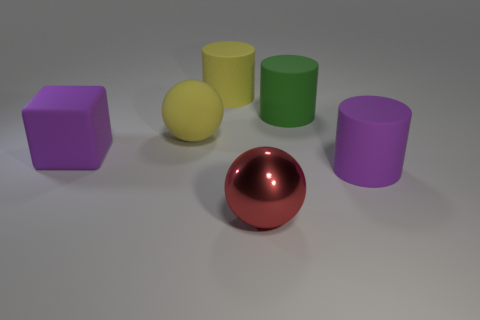Subtract 1 cylinders. How many cylinders are left? 2 Add 3 cylinders. How many objects exist? 9 Add 2 big cylinders. How many big cylinders exist? 5 Subtract 0 gray blocks. How many objects are left? 6 Subtract all spheres. How many objects are left? 4 Subtract all large red shiny things. Subtract all large purple matte cylinders. How many objects are left? 4 Add 3 spheres. How many spheres are left? 5 